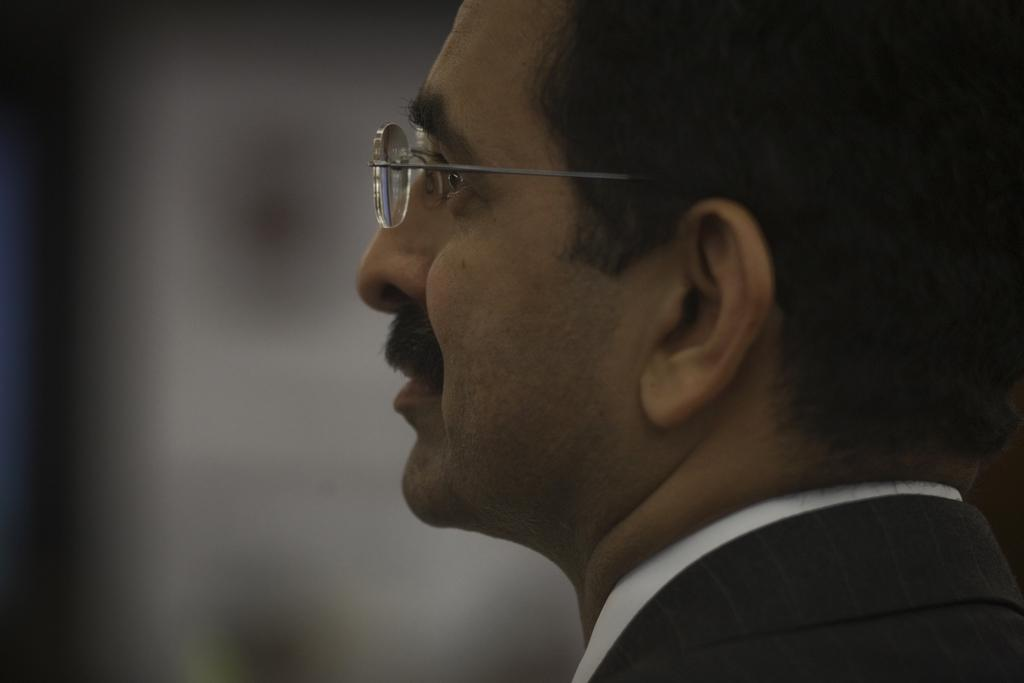What is located on the right side of the image? There is a man on the right side of the image. What can be observed about the man's appearance? The man is wearing spectacles. How would you describe the background of the image? The background of the image is blurry. What language is the man speaking in the image? There is no indication of the man speaking in the image, so it cannot be determined which language he might be using. 